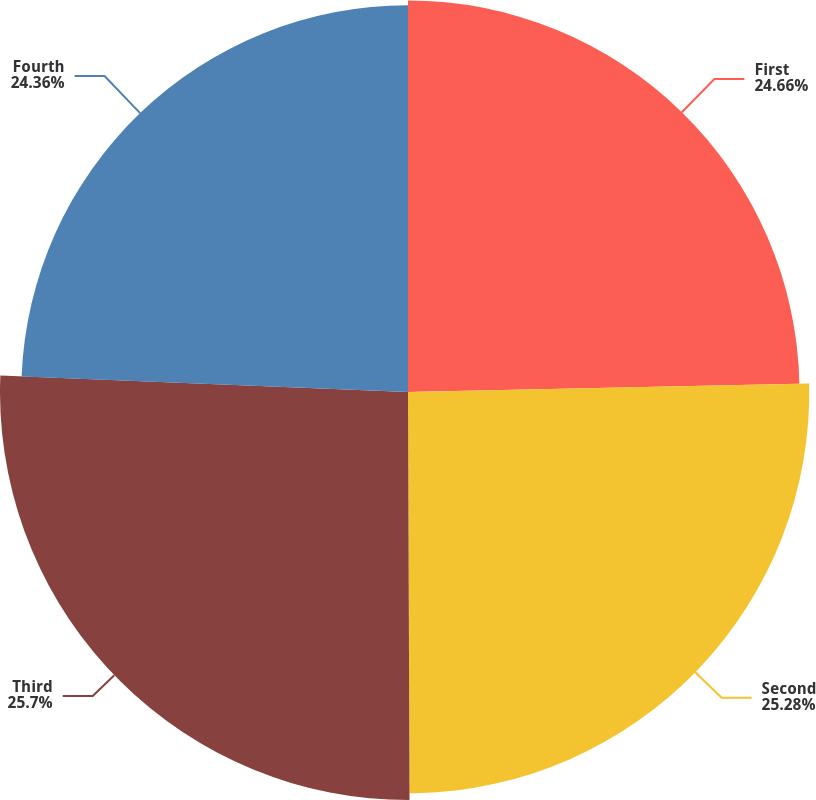Convert chart to OTSL. <chart><loc_0><loc_0><loc_500><loc_500><pie_chart><fcel>First<fcel>Second<fcel>Third<fcel>Fourth<nl><fcel>24.66%<fcel>25.28%<fcel>25.7%<fcel>24.36%<nl></chart> 